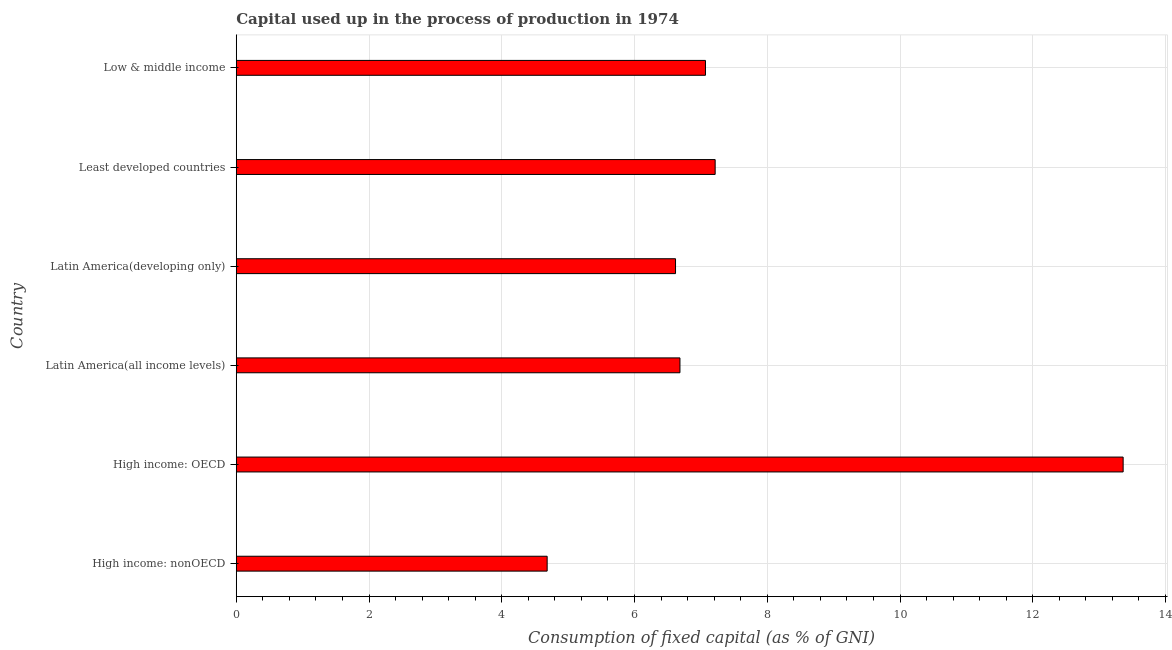Does the graph contain any zero values?
Ensure brevity in your answer.  No. What is the title of the graph?
Your response must be concise. Capital used up in the process of production in 1974. What is the label or title of the X-axis?
Make the answer very short. Consumption of fixed capital (as % of GNI). What is the label or title of the Y-axis?
Give a very brief answer. Country. What is the consumption of fixed capital in Latin America(all income levels)?
Your answer should be very brief. 6.68. Across all countries, what is the maximum consumption of fixed capital?
Your answer should be compact. 13.36. Across all countries, what is the minimum consumption of fixed capital?
Keep it short and to the point. 4.68. In which country was the consumption of fixed capital maximum?
Your answer should be compact. High income: OECD. In which country was the consumption of fixed capital minimum?
Ensure brevity in your answer.  High income: nonOECD. What is the sum of the consumption of fixed capital?
Your answer should be compact. 45.63. What is the difference between the consumption of fixed capital in High income: OECD and Latin America(developing only)?
Provide a short and direct response. 6.74. What is the average consumption of fixed capital per country?
Make the answer very short. 7.61. What is the median consumption of fixed capital?
Your answer should be compact. 6.88. What is the ratio of the consumption of fixed capital in Latin America(developing only) to that in Low & middle income?
Make the answer very short. 0.94. What is the difference between the highest and the second highest consumption of fixed capital?
Your response must be concise. 6.15. Is the sum of the consumption of fixed capital in Latin America(all income levels) and Latin America(developing only) greater than the maximum consumption of fixed capital across all countries?
Provide a short and direct response. No. What is the difference between the highest and the lowest consumption of fixed capital?
Offer a very short reply. 8.68. In how many countries, is the consumption of fixed capital greater than the average consumption of fixed capital taken over all countries?
Your answer should be compact. 1. How many countries are there in the graph?
Your answer should be very brief. 6. What is the Consumption of fixed capital (as % of GNI) in High income: nonOECD?
Keep it short and to the point. 4.68. What is the Consumption of fixed capital (as % of GNI) in High income: OECD?
Provide a succinct answer. 13.36. What is the Consumption of fixed capital (as % of GNI) of Latin America(all income levels)?
Keep it short and to the point. 6.68. What is the Consumption of fixed capital (as % of GNI) of Latin America(developing only)?
Provide a short and direct response. 6.62. What is the Consumption of fixed capital (as % of GNI) in Least developed countries?
Provide a succinct answer. 7.22. What is the Consumption of fixed capital (as % of GNI) of Low & middle income?
Keep it short and to the point. 7.07. What is the difference between the Consumption of fixed capital (as % of GNI) in High income: nonOECD and High income: OECD?
Provide a short and direct response. -8.68. What is the difference between the Consumption of fixed capital (as % of GNI) in High income: nonOECD and Latin America(all income levels)?
Ensure brevity in your answer.  -2. What is the difference between the Consumption of fixed capital (as % of GNI) in High income: nonOECD and Latin America(developing only)?
Provide a short and direct response. -1.93. What is the difference between the Consumption of fixed capital (as % of GNI) in High income: nonOECD and Least developed countries?
Provide a succinct answer. -2.53. What is the difference between the Consumption of fixed capital (as % of GNI) in High income: nonOECD and Low & middle income?
Your answer should be very brief. -2.39. What is the difference between the Consumption of fixed capital (as % of GNI) in High income: OECD and Latin America(all income levels)?
Provide a short and direct response. 6.68. What is the difference between the Consumption of fixed capital (as % of GNI) in High income: OECD and Latin America(developing only)?
Provide a short and direct response. 6.74. What is the difference between the Consumption of fixed capital (as % of GNI) in High income: OECD and Least developed countries?
Offer a terse response. 6.15. What is the difference between the Consumption of fixed capital (as % of GNI) in High income: OECD and Low & middle income?
Offer a terse response. 6.29. What is the difference between the Consumption of fixed capital (as % of GNI) in Latin America(all income levels) and Latin America(developing only)?
Offer a terse response. 0.07. What is the difference between the Consumption of fixed capital (as % of GNI) in Latin America(all income levels) and Least developed countries?
Your response must be concise. -0.53. What is the difference between the Consumption of fixed capital (as % of GNI) in Latin America(all income levels) and Low & middle income?
Ensure brevity in your answer.  -0.38. What is the difference between the Consumption of fixed capital (as % of GNI) in Latin America(developing only) and Least developed countries?
Your response must be concise. -0.6. What is the difference between the Consumption of fixed capital (as % of GNI) in Latin America(developing only) and Low & middle income?
Your answer should be compact. -0.45. What is the difference between the Consumption of fixed capital (as % of GNI) in Least developed countries and Low & middle income?
Offer a very short reply. 0.15. What is the ratio of the Consumption of fixed capital (as % of GNI) in High income: nonOECD to that in High income: OECD?
Ensure brevity in your answer.  0.35. What is the ratio of the Consumption of fixed capital (as % of GNI) in High income: nonOECD to that in Latin America(all income levels)?
Provide a short and direct response. 0.7. What is the ratio of the Consumption of fixed capital (as % of GNI) in High income: nonOECD to that in Latin America(developing only)?
Give a very brief answer. 0.71. What is the ratio of the Consumption of fixed capital (as % of GNI) in High income: nonOECD to that in Least developed countries?
Make the answer very short. 0.65. What is the ratio of the Consumption of fixed capital (as % of GNI) in High income: nonOECD to that in Low & middle income?
Ensure brevity in your answer.  0.66. What is the ratio of the Consumption of fixed capital (as % of GNI) in High income: OECD to that in Latin America(all income levels)?
Give a very brief answer. 2. What is the ratio of the Consumption of fixed capital (as % of GNI) in High income: OECD to that in Latin America(developing only)?
Offer a very short reply. 2.02. What is the ratio of the Consumption of fixed capital (as % of GNI) in High income: OECD to that in Least developed countries?
Make the answer very short. 1.85. What is the ratio of the Consumption of fixed capital (as % of GNI) in High income: OECD to that in Low & middle income?
Offer a very short reply. 1.89. What is the ratio of the Consumption of fixed capital (as % of GNI) in Latin America(all income levels) to that in Latin America(developing only)?
Provide a succinct answer. 1.01. What is the ratio of the Consumption of fixed capital (as % of GNI) in Latin America(all income levels) to that in Least developed countries?
Provide a succinct answer. 0.93. What is the ratio of the Consumption of fixed capital (as % of GNI) in Latin America(all income levels) to that in Low & middle income?
Provide a short and direct response. 0.95. What is the ratio of the Consumption of fixed capital (as % of GNI) in Latin America(developing only) to that in Least developed countries?
Your answer should be compact. 0.92. What is the ratio of the Consumption of fixed capital (as % of GNI) in Latin America(developing only) to that in Low & middle income?
Offer a terse response. 0.94. 